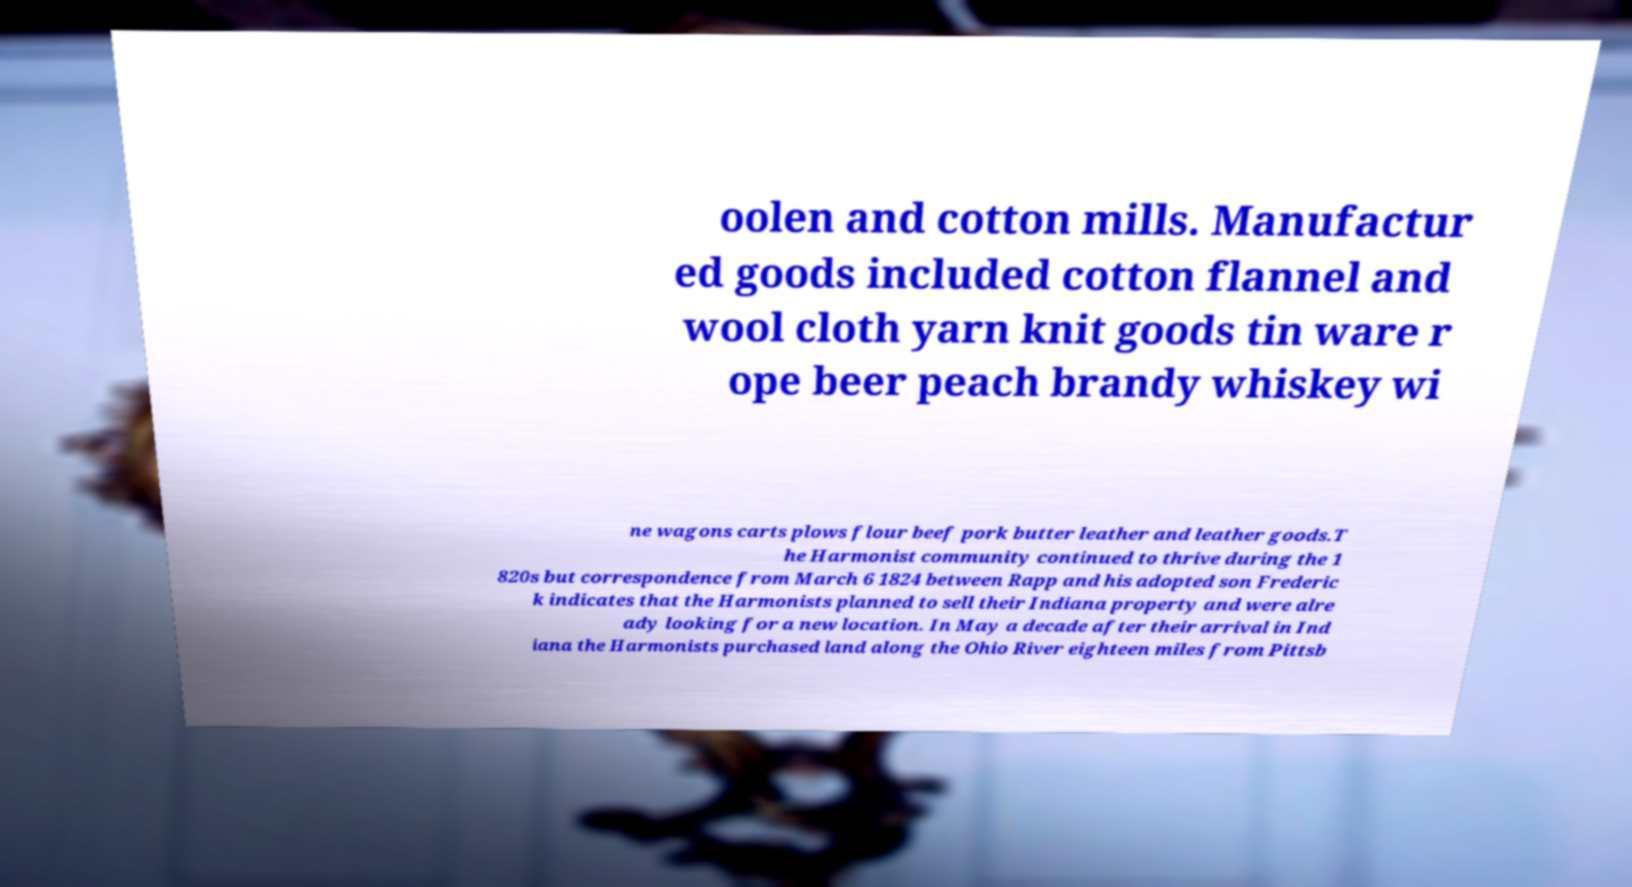Please read and relay the text visible in this image. What does it say? oolen and cotton mills. Manufactur ed goods included cotton flannel and wool cloth yarn knit goods tin ware r ope beer peach brandy whiskey wi ne wagons carts plows flour beef pork butter leather and leather goods.T he Harmonist community continued to thrive during the 1 820s but correspondence from March 6 1824 between Rapp and his adopted son Frederic k indicates that the Harmonists planned to sell their Indiana property and were alre ady looking for a new location. In May a decade after their arrival in Ind iana the Harmonists purchased land along the Ohio River eighteen miles from Pittsb 